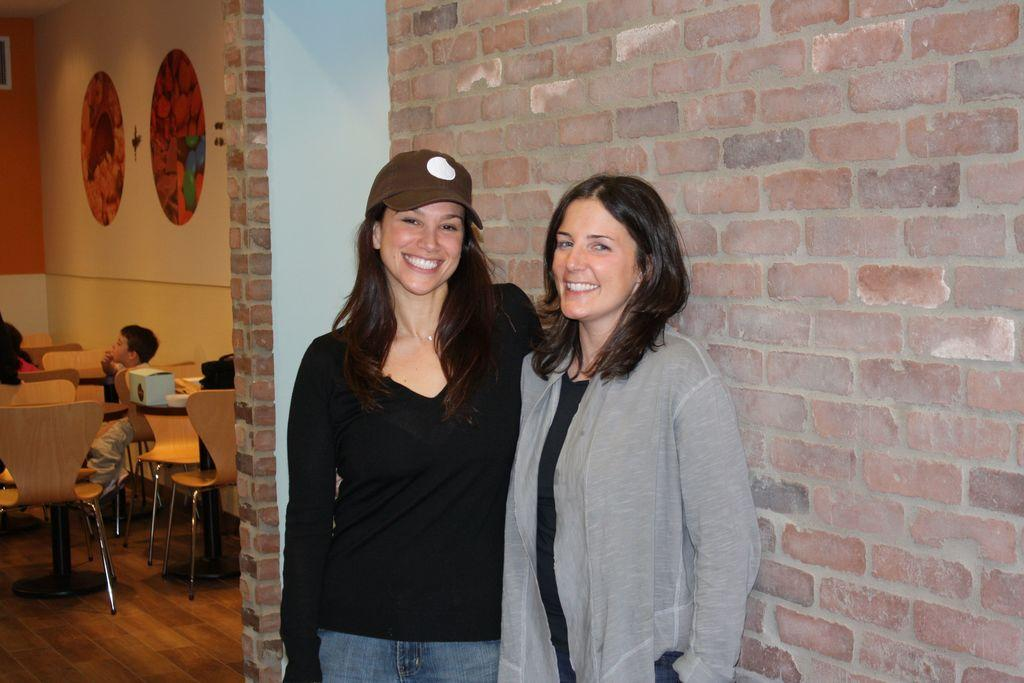How many women are in the image? There are two women in the image. What are the women doing in the image? The women are standing and smiling. What can be seen in the background of the image? In the background, there are children sitting on chairs, and there is a painting on the wall. What type of beetle can be seen crawling on the painting in the image? There is no beetle present in the image, and the painting is not mentioned as having any insects on it. 